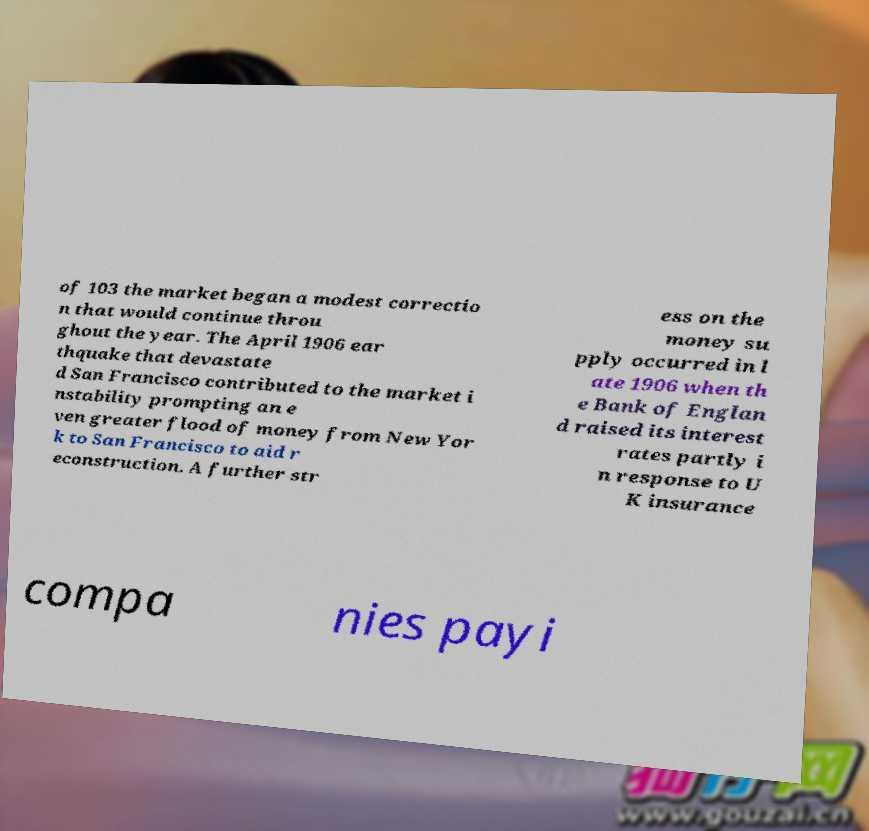Could you assist in decoding the text presented in this image and type it out clearly? of 103 the market began a modest correctio n that would continue throu ghout the year. The April 1906 ear thquake that devastate d San Francisco contributed to the market i nstability prompting an e ven greater flood of money from New Yor k to San Francisco to aid r econstruction. A further str ess on the money su pply occurred in l ate 1906 when th e Bank of Englan d raised its interest rates partly i n response to U K insurance compa nies payi 